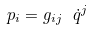<formula> <loc_0><loc_0><loc_500><loc_500>p _ { i } = g _ { i j } \ \dot { q } ^ { j }</formula> 